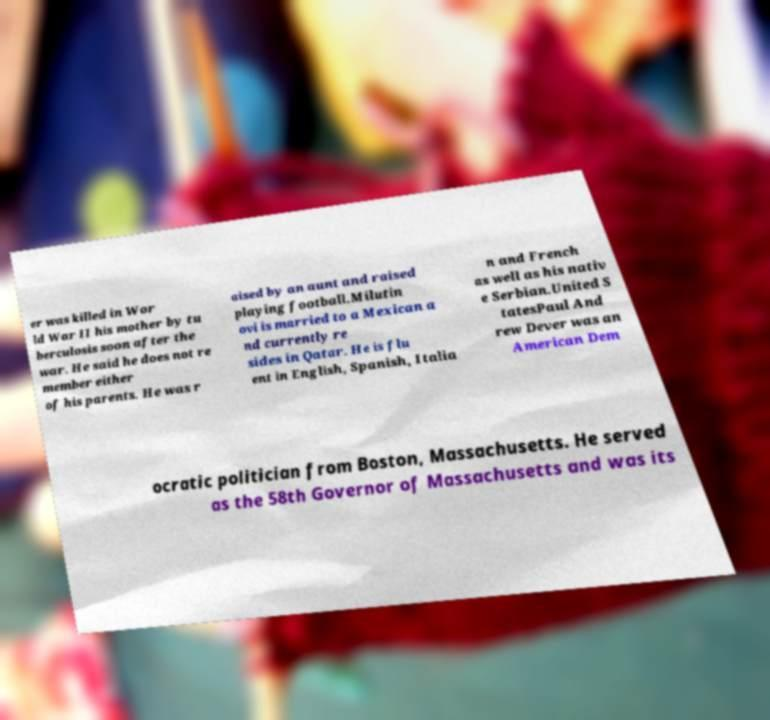There's text embedded in this image that I need extracted. Can you transcribe it verbatim? er was killed in Wor ld War II his mother by tu berculosis soon after the war. He said he does not re member either of his parents. He was r aised by an aunt and raised playing football.Milutin ovi is married to a Mexican a nd currently re sides in Qatar. He is flu ent in English, Spanish, Italia n and French as well as his nativ e Serbian.United S tatesPaul And rew Dever was an American Dem ocratic politician from Boston, Massachusetts. He served as the 58th Governor of Massachusetts and was its 